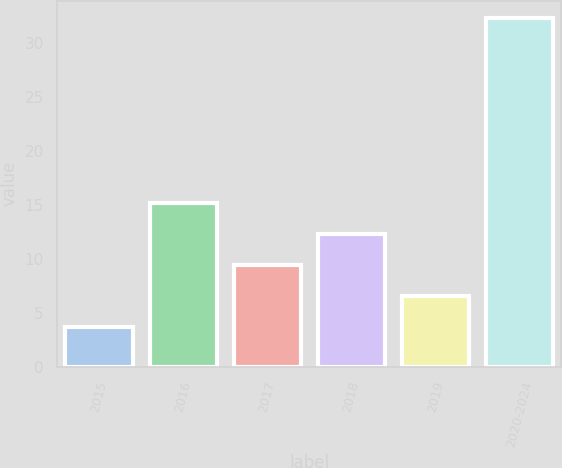<chart> <loc_0><loc_0><loc_500><loc_500><bar_chart><fcel>2015<fcel>2016<fcel>2017<fcel>2018<fcel>2019<fcel>2020-2024<nl><fcel>3.7<fcel>15.14<fcel>9.42<fcel>12.28<fcel>6.56<fcel>32.3<nl></chart> 